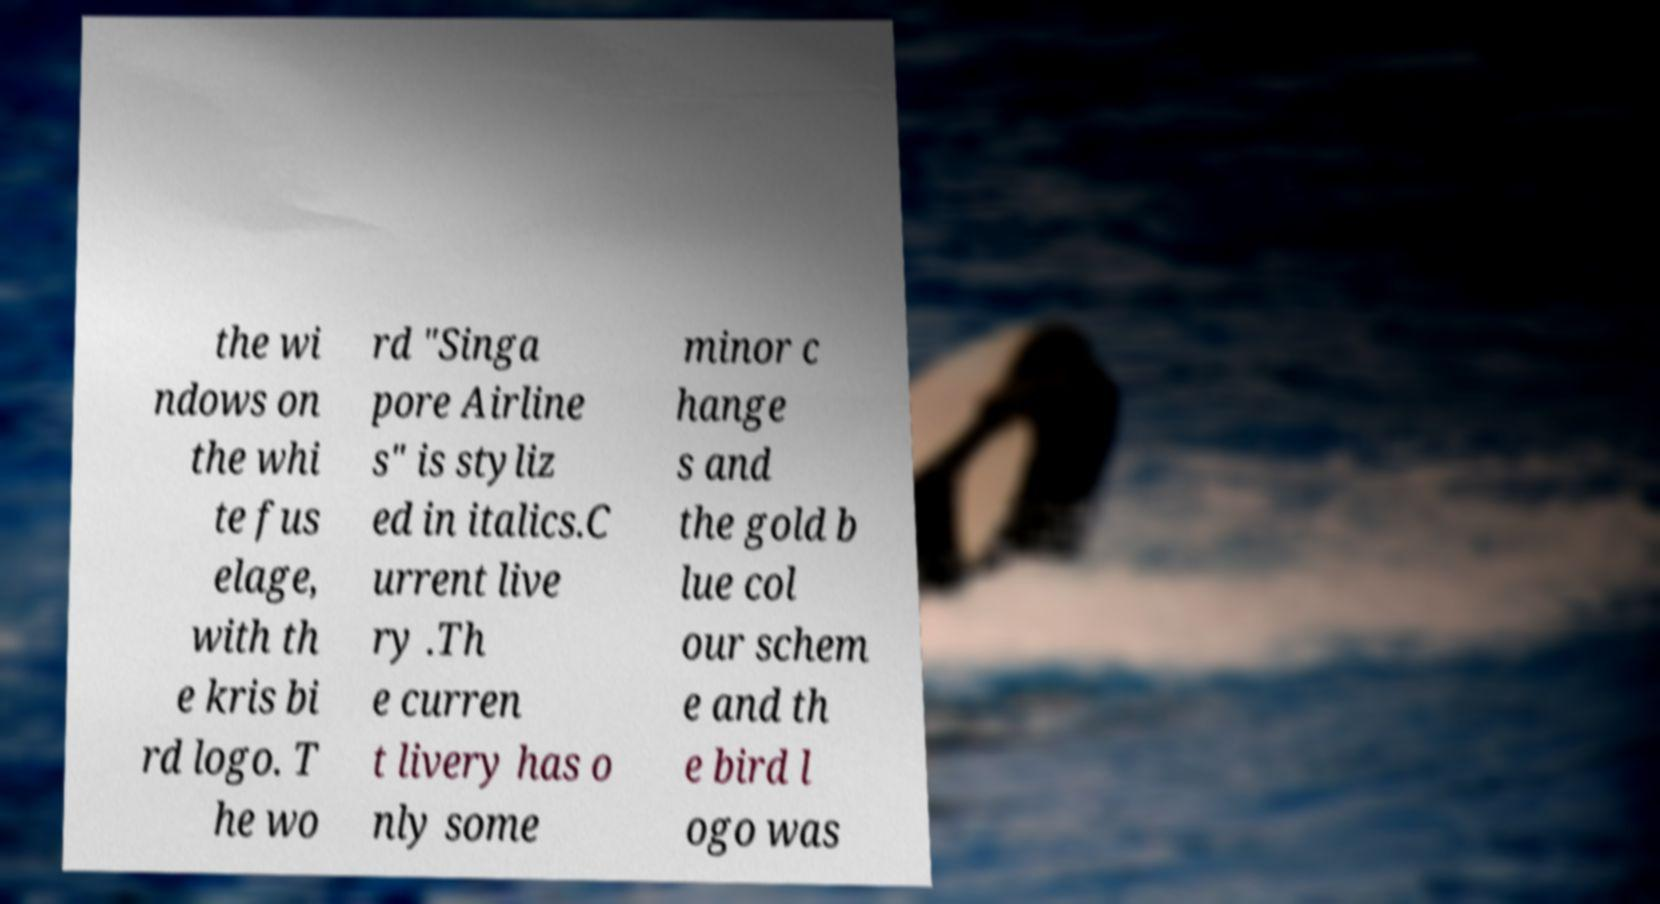Could you extract and type out the text from this image? the wi ndows on the whi te fus elage, with th e kris bi rd logo. T he wo rd "Singa pore Airline s" is styliz ed in italics.C urrent live ry .Th e curren t livery has o nly some minor c hange s and the gold b lue col our schem e and th e bird l ogo was 